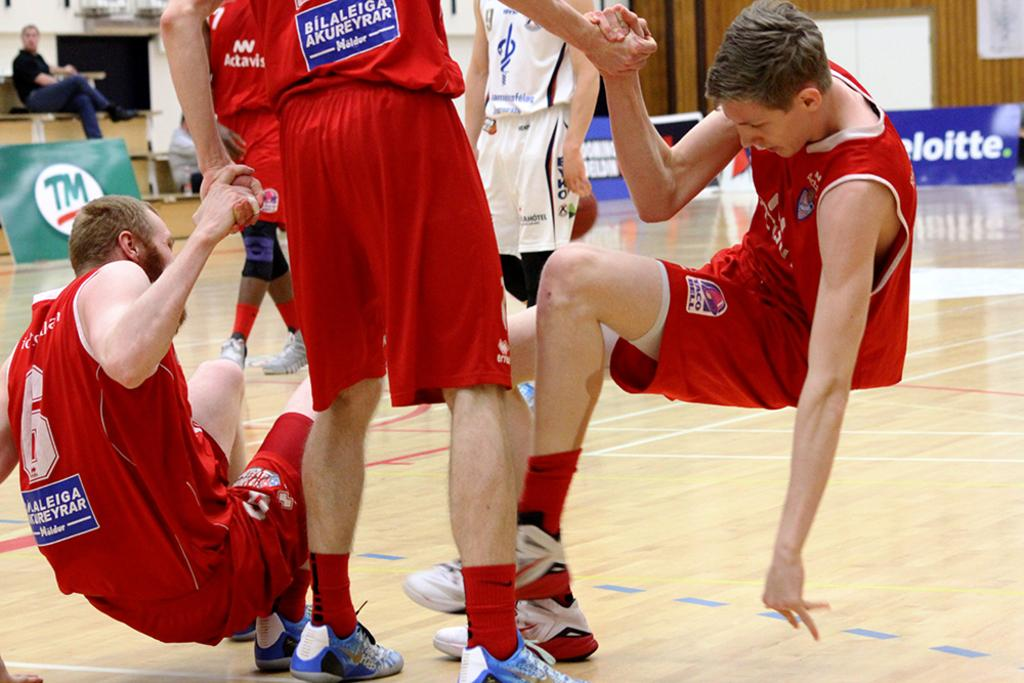<image>
Create a compact narrative representing the image presented. A man whose team is sponsored by Taco Bell is helping up his teammate. 